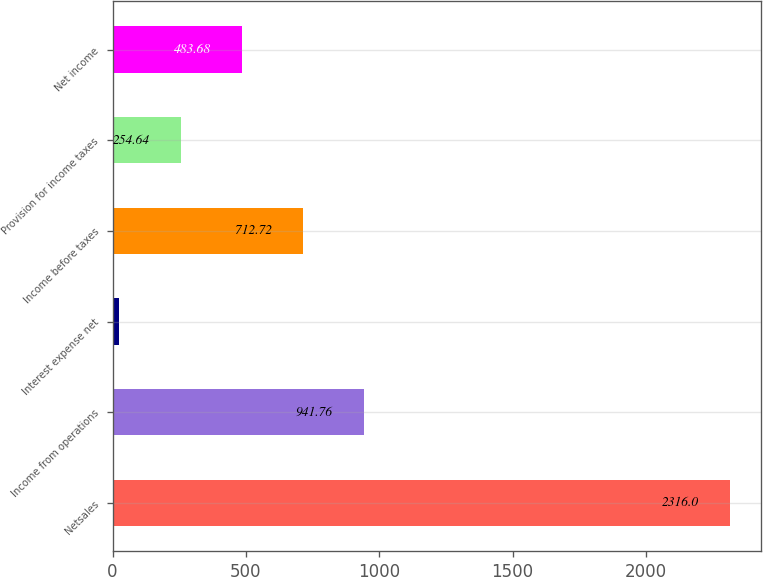Convert chart. <chart><loc_0><loc_0><loc_500><loc_500><bar_chart><fcel>Netsales<fcel>Income from operations<fcel>Interest expense net<fcel>Income before taxes<fcel>Provision for income taxes<fcel>Net income<nl><fcel>2316<fcel>941.76<fcel>25.6<fcel>712.72<fcel>254.64<fcel>483.68<nl></chart> 